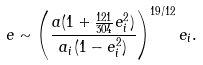Convert formula to latex. <formula><loc_0><loc_0><loc_500><loc_500>e \sim \left ( \frac { a ( 1 + \frac { 1 2 1 } { 3 0 4 } e _ { i } ^ { 2 } ) } { a _ { i } ( 1 - e _ { i } ^ { 2 } ) } \right ) ^ { 1 9 / 1 2 } e _ { i } .</formula> 